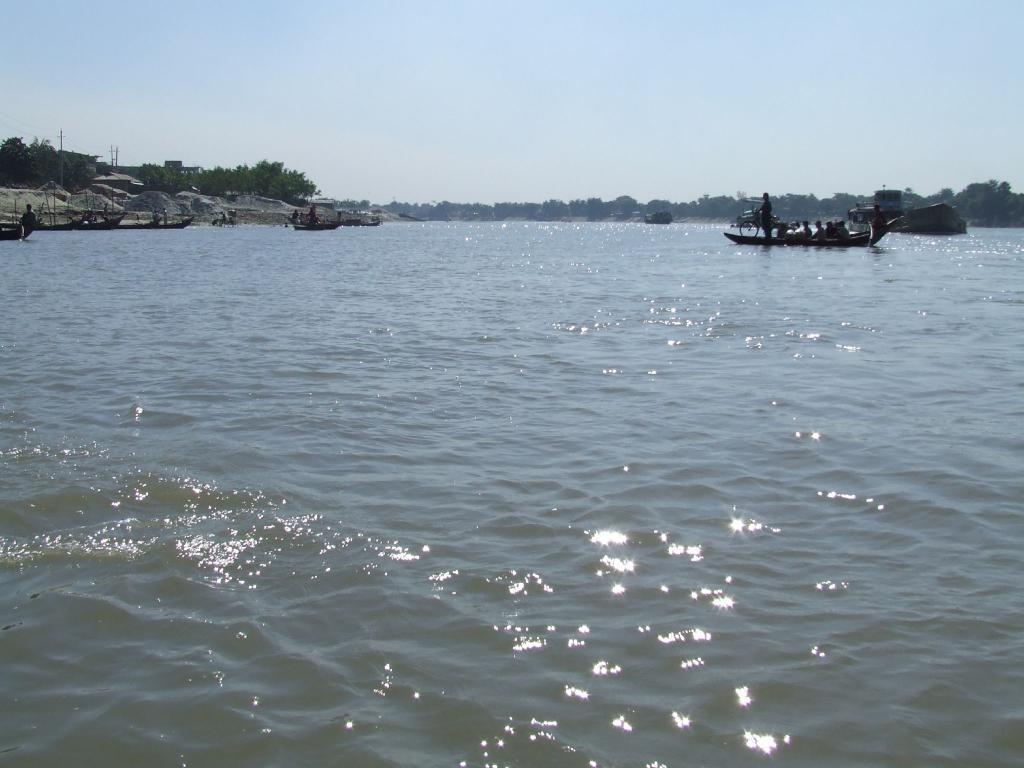Can you describe this image briefly? In this image we can see a river, there are people sailing the boats, we can see few rock mountains and trees, in the background we can see the sky. 